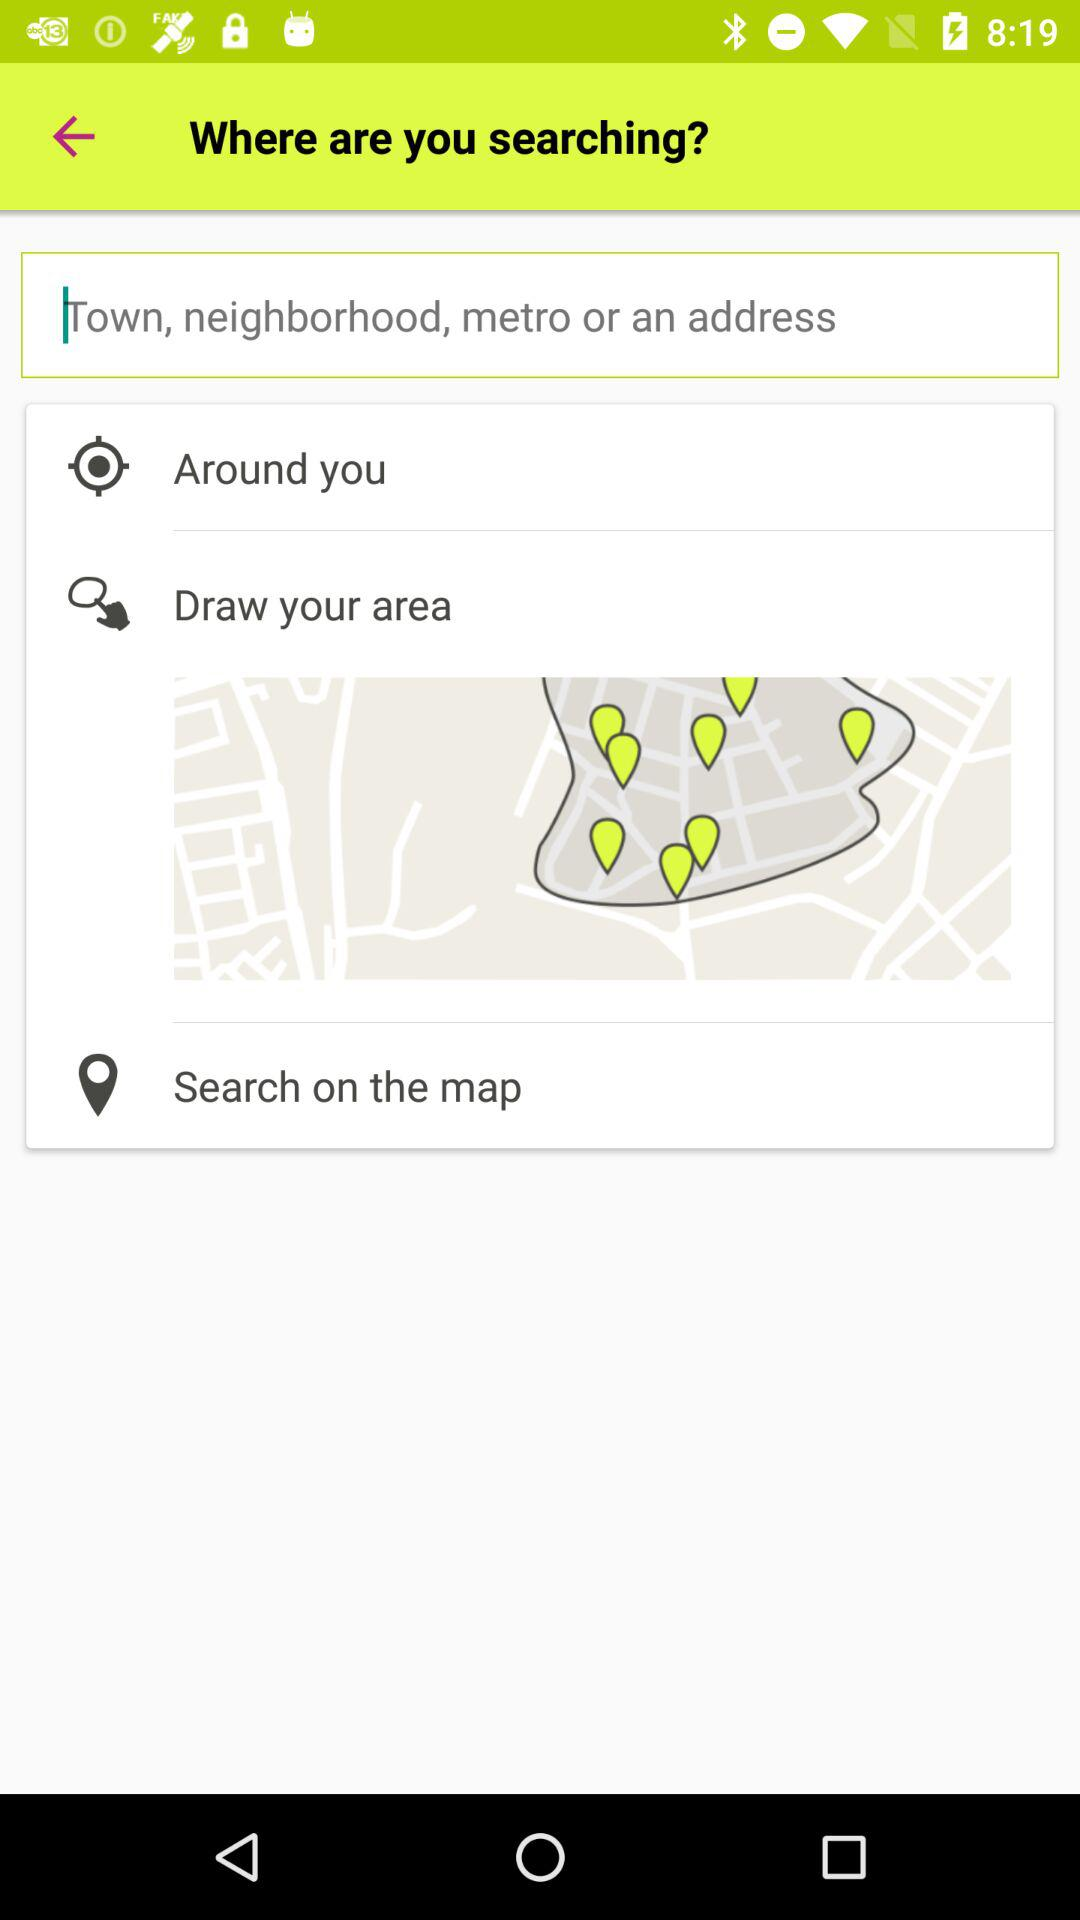What can we search for through the application? You can search for a town, neighborhood, metro or address through the application. 